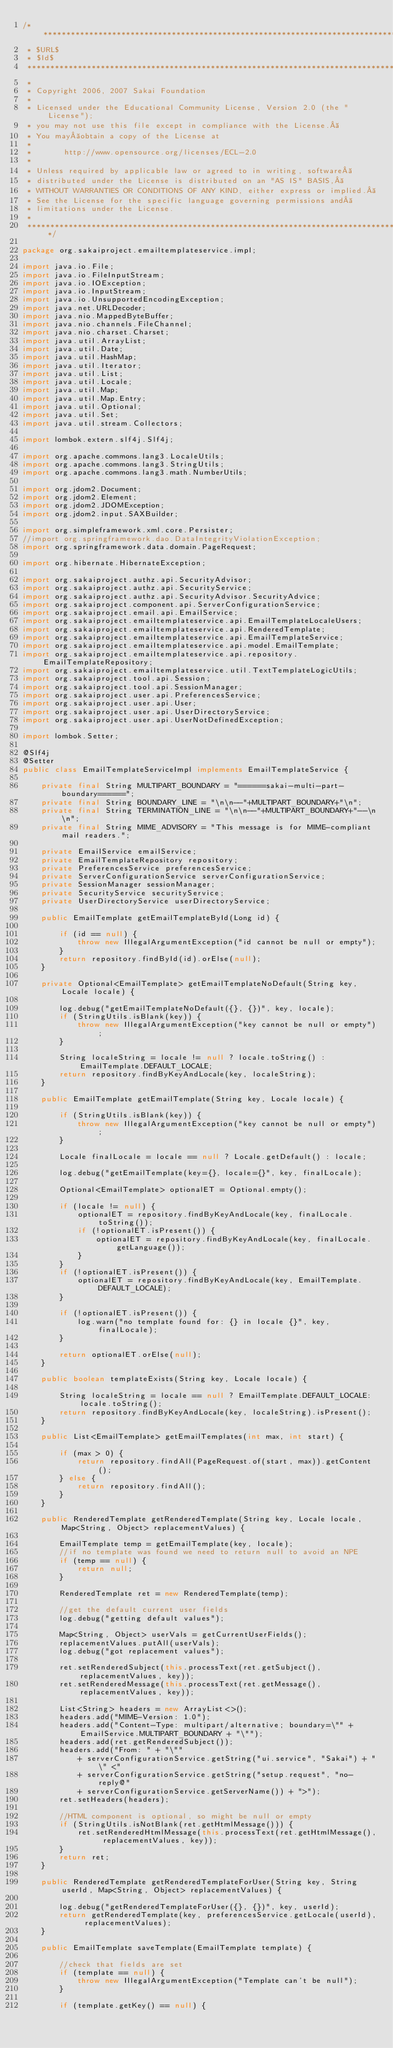Convert code to text. <code><loc_0><loc_0><loc_500><loc_500><_Java_>/**********************************************************************************
 * $URL$
 * $Id$
 ***********************************************************************************
 *
 * Copyright 2006, 2007 Sakai Foundation
 *
 * Licensed under the Educational Community License, Version 2.0 (the "License");
 * you may not use this file except in compliance with the License. 
 * You may obtain a copy of the License at
 *
 *       http://www.opensource.org/licenses/ECL-2.0
 *
 * Unless required by applicable law or agreed to in writing, software 
 * distributed under the License is distributed on an "AS IS" BASIS, 
 * WITHOUT WARRANTIES OR CONDITIONS OF ANY KIND, either express or implied. 
 * See the License for the specific language governing permissions and 
 * limitations under the License.
 *
 **********************************************************************************/

package org.sakaiproject.emailtemplateservice.impl;

import java.io.File;
import java.io.FileInputStream;
import java.io.IOException;
import java.io.InputStream;
import java.io.UnsupportedEncodingException;
import java.net.URLDecoder;
import java.nio.MappedByteBuffer;
import java.nio.channels.FileChannel;
import java.nio.charset.Charset;
import java.util.ArrayList;
import java.util.Date;
import java.util.HashMap;
import java.util.Iterator;
import java.util.List;
import java.util.Locale;
import java.util.Map;
import java.util.Map.Entry;
import java.util.Optional;
import java.util.Set;
import java.util.stream.Collectors;

import lombok.extern.slf4j.Slf4j;

import org.apache.commons.lang3.LocaleUtils;
import org.apache.commons.lang3.StringUtils;
import org.apache.commons.lang3.math.NumberUtils;

import org.jdom2.Document;
import org.jdom2.Element;
import org.jdom2.JDOMException;
import org.jdom2.input.SAXBuilder;

import org.simpleframework.xml.core.Persister;
//import org.springframework.dao.DataIntegrityViolationException;
import org.springframework.data.domain.PageRequest;

import org.hibernate.HibernateException;

import org.sakaiproject.authz.api.SecurityAdvisor;
import org.sakaiproject.authz.api.SecurityService;
import org.sakaiproject.authz.api.SecurityAdvisor.SecurityAdvice;
import org.sakaiproject.component.api.ServerConfigurationService;
import org.sakaiproject.email.api.EmailService;
import org.sakaiproject.emailtemplateservice.api.EmailTemplateLocaleUsers;
import org.sakaiproject.emailtemplateservice.api.RenderedTemplate;
import org.sakaiproject.emailtemplateservice.api.EmailTemplateService;
import org.sakaiproject.emailtemplateservice.api.model.EmailTemplate;
import org.sakaiproject.emailtemplateservice.api.repository.EmailTemplateRepository;
import org.sakaiproject.emailtemplateservice.util.TextTemplateLogicUtils;
import org.sakaiproject.tool.api.Session;
import org.sakaiproject.tool.api.SessionManager;
import org.sakaiproject.user.api.PreferencesService;
import org.sakaiproject.user.api.User;
import org.sakaiproject.user.api.UserDirectoryService;
import org.sakaiproject.user.api.UserNotDefinedException;

import lombok.Setter;

@Slf4j
@Setter
public class EmailTemplateServiceImpl implements EmailTemplateService {

    private final String MULTIPART_BOUNDARY = "======sakai-multi-part-boundary======";
    private final String BOUNDARY_LINE = "\n\n--"+MULTIPART_BOUNDARY+"\n";
    private final String TERMINATION_LINE = "\n\n--"+MULTIPART_BOUNDARY+"--\n\n";
    private final String MIME_ADVISORY = "This message is for MIME-compliant mail readers.";

    private EmailService emailService;
    private EmailTemplateRepository repository;
    private PreferencesService preferencesService;
    private ServerConfigurationService serverConfigurationService;
    private SessionManager sessionManager;
    private SecurityService securityService;
    private UserDirectoryService userDirectoryService;

    public EmailTemplate getEmailTemplateById(Long id) {

        if (id == null) {
            throw new IllegalArgumentException("id cannot be null or empty");
        }
        return repository.findById(id).orElse(null);
    }

    private Optional<EmailTemplate> getEmailTemplateNoDefault(String key, Locale locale) {

        log.debug("getEmailTemplateNoDefault({}, {})", key, locale);
        if (StringUtils.isBlank(key)) {
            throw new IllegalArgumentException("key cannot be null or empty");
        }

        String localeString = locale != null ? locale.toString() : EmailTemplate.DEFAULT_LOCALE;
        return repository.findByKeyAndLocale(key, localeString);
    }

    public EmailTemplate getEmailTemplate(String key, Locale locale) {

        if (StringUtils.isBlank(key)) {
            throw new IllegalArgumentException("key cannot be null or empty");
        }

        Locale finalLocale = locale == null ? Locale.getDefault() : locale;

        log.debug("getEmailTemplate(key={}, locale={}", key, finalLocale);

        Optional<EmailTemplate> optionalET = Optional.empty();

        if (locale != null) {
            optionalET = repository.findByKeyAndLocale(key, finalLocale.toString());
            if (!optionalET.isPresent()) {
                optionalET = repository.findByKeyAndLocale(key, finalLocale.getLanguage());
            }
        }
        if (!optionalET.isPresent()) {
            optionalET = repository.findByKeyAndLocale(key, EmailTemplate.DEFAULT_LOCALE);
        }

        if (!optionalET.isPresent()) {
            log.warn("no template found for: {} in locale {}", key, finalLocale);
        }

        return optionalET.orElse(null);
    }

    public boolean templateExists(String key, Locale locale) {

        String localeString = locale == null ? EmailTemplate.DEFAULT_LOCALE: locale.toString();
        return repository.findByKeyAndLocale(key, localeString).isPresent();
    }

    public List<EmailTemplate> getEmailTemplates(int max, int start) {

        if (max > 0) {
            return repository.findAll(PageRequest.of(start, max)).getContent();
        } else {
            return repository.findAll();
        }
    }

    public RenderedTemplate getRenderedTemplate(String key, Locale locale, Map<String, Object> replacementValues) {

        EmailTemplate temp = getEmailTemplate(key, locale);
        //if no template was found we need to return null to avoid an NPE
        if (temp == null) {
            return null;
        }
 
        RenderedTemplate ret = new RenderedTemplate(temp);

        //get the default current user fields
        log.debug("getting default values");

        Map<String, Object> userVals = getCurrentUserFields();
        replacementValues.putAll(userVals);
        log.debug("got replacement values");

        ret.setRenderedSubject(this.processText(ret.getSubject(), replacementValues, key));
        ret.setRenderedMessage(this.processText(ret.getMessage(), replacementValues, key));

        List<String> headers = new ArrayList<>();
        headers.add("MIME-Version: 1.0");
        headers.add("Content-Type: multipart/alternative; boundary=\"" + EmailService.MULTIPART_BOUNDARY + "\"");
        headers.add(ret.getRenderedSubject());
        headers.add("From: " + "\""
            + serverConfigurationService.getString("ui.service", "Sakai") + "\" <"
            + serverConfigurationService.getString("setup.request", "no-reply@"
            + serverConfigurationService.getServerName()) + ">");
        ret.setHeaders(headers);

        //HTML component is optional, so might be null or empty
        if (StringUtils.isNotBlank(ret.getHtmlMessage())) {
            ret.setRenderedHtmlMessage(this.processText(ret.getHtmlMessage(), replacementValues, key));
        }
        return ret;
    }

    public RenderedTemplate getRenderedTemplateForUser(String key, String userId, Map<String, Object> replacementValues) {

        log.debug("getRenderedTemplateForUser({}, {})", key, userId);
        return getRenderedTemplate(key, preferencesService.getLocale(userId), replacementValues);
    }

    public EmailTemplate saveTemplate(EmailTemplate template) {

        //check that fields are set
        if (template == null) {
            throw new IllegalArgumentException("Template can't be null");
        }

        if (template.getKey() == null) {</code> 